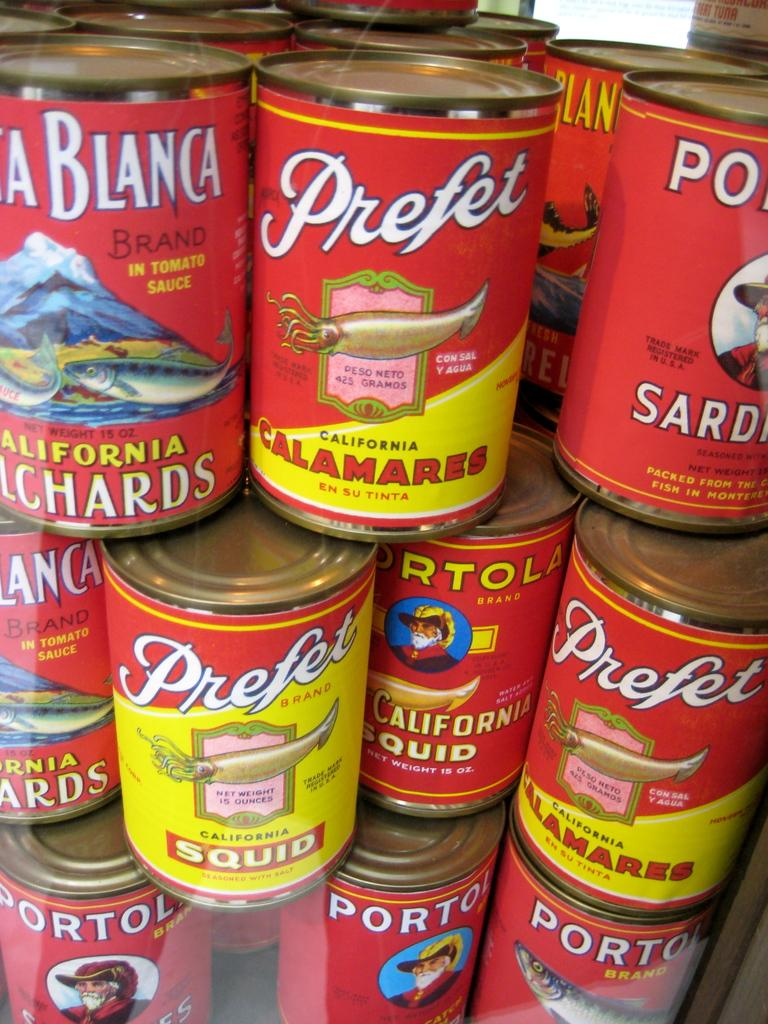Provide a one-sentence caption for the provided image. Numerous cans of seafood called Prefet are stacked. 